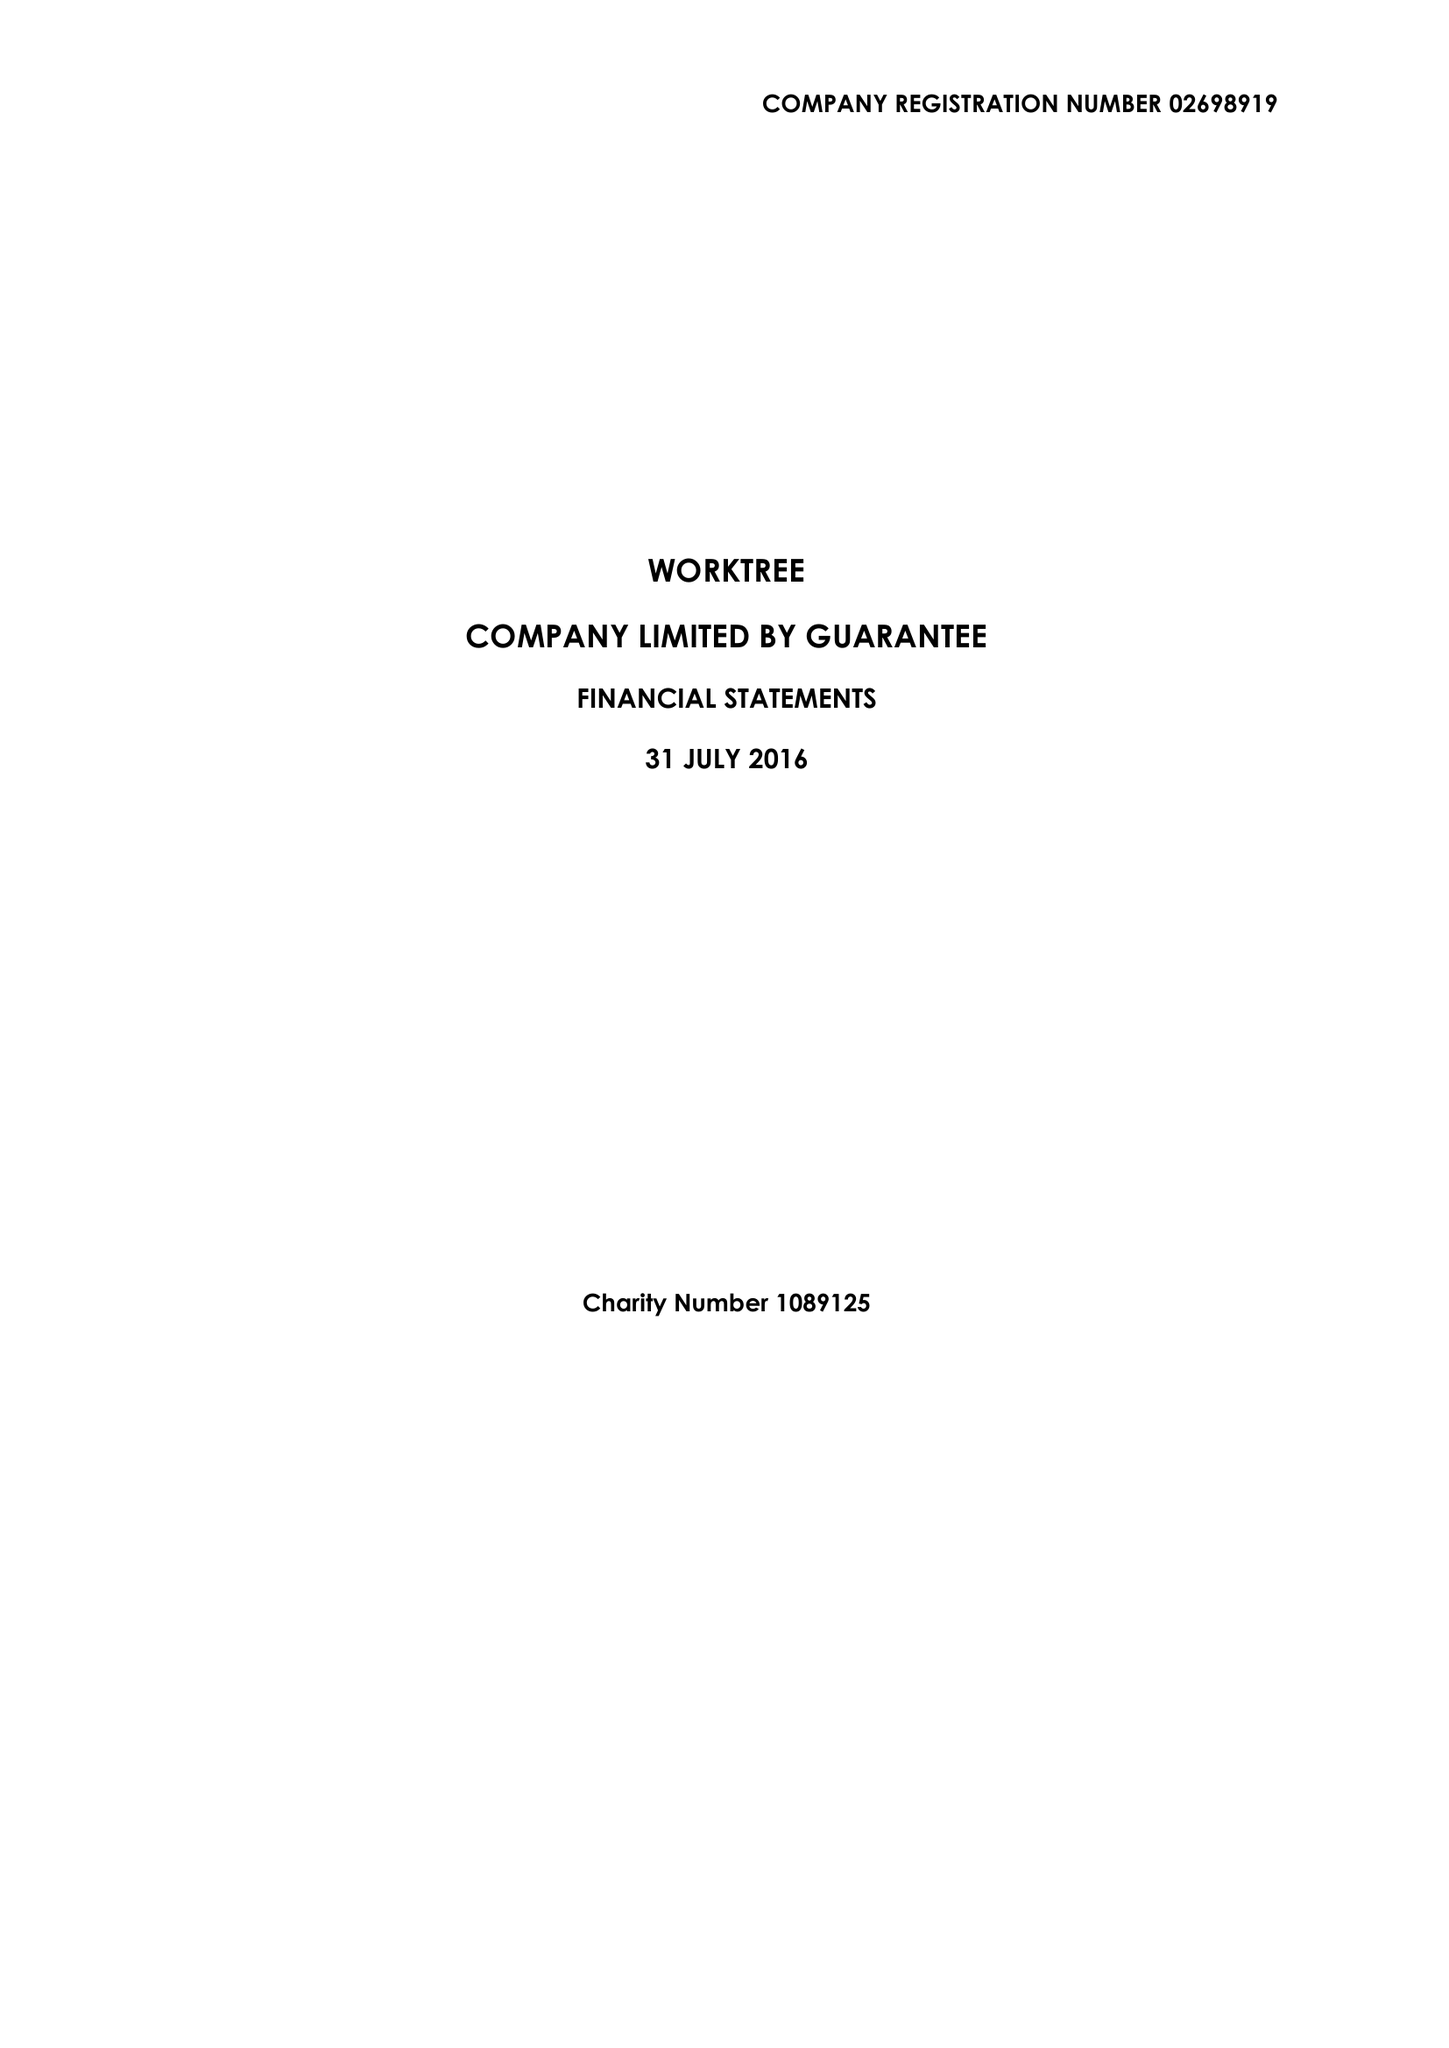What is the value for the charity_name?
Answer the question using a single word or phrase. Worktree 